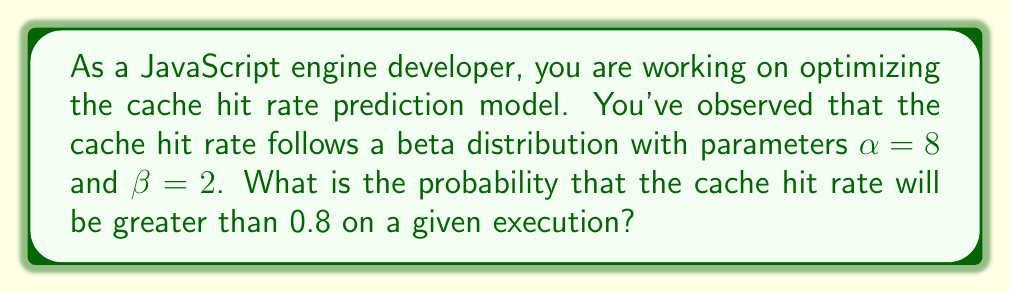What is the answer to this math problem? To solve this problem, we need to use the properties of the beta distribution and calculate the probability using the cumulative distribution function (CDF).

1. The beta distribution with parameters $\alpha$ and $\beta$ has the following probability density function (PDF):

   $$f(x; \alpha, \beta) = \frac{x^{\alpha-1}(1-x)^{\beta-1}}{B(\alpha, \beta)}$$

   where $B(\alpha, \beta)$ is the beta function.

2. We are given $\alpha = 8$ and $\beta = 2$.

3. We want to find $P(X > 0.8)$, where $X$ is the cache hit rate.

4. This is equivalent to $1 - P(X \leq 0.8)$, where $P(X \leq 0.8)$ is the CDF of the beta distribution at $x = 0.8$.

5. The CDF of the beta distribution is the regularized incomplete beta function:

   $$P(X \leq x) = I_x(\alpha, \beta) = \frac{B(x; \alpha, \beta)}{B(\alpha, \beta)}$$

   where $B(x; \alpha, \beta)$ is the incomplete beta function.

6. We need to calculate:

   $$P(X > 0.8) = 1 - I_{0.8}(8, 2)$$

7. The regularized incomplete beta function $I_{0.8}(8, 2)$ can be calculated using statistical software or numerical integration. Using a calculator or programming language with this function, we find:

   $$I_{0.8}(8, 2) \approx 0.8926$$

8. Therefore:

   $$P(X > 0.8) = 1 - 0.8926 \approx 0.1074$$

Thus, the probability that the cache hit rate will be greater than 0.8 is approximately 0.1074 or 10.74%.
Answer: The probability that the cache hit rate will be greater than 0.8 is approximately 0.1074 or 10.74%. 